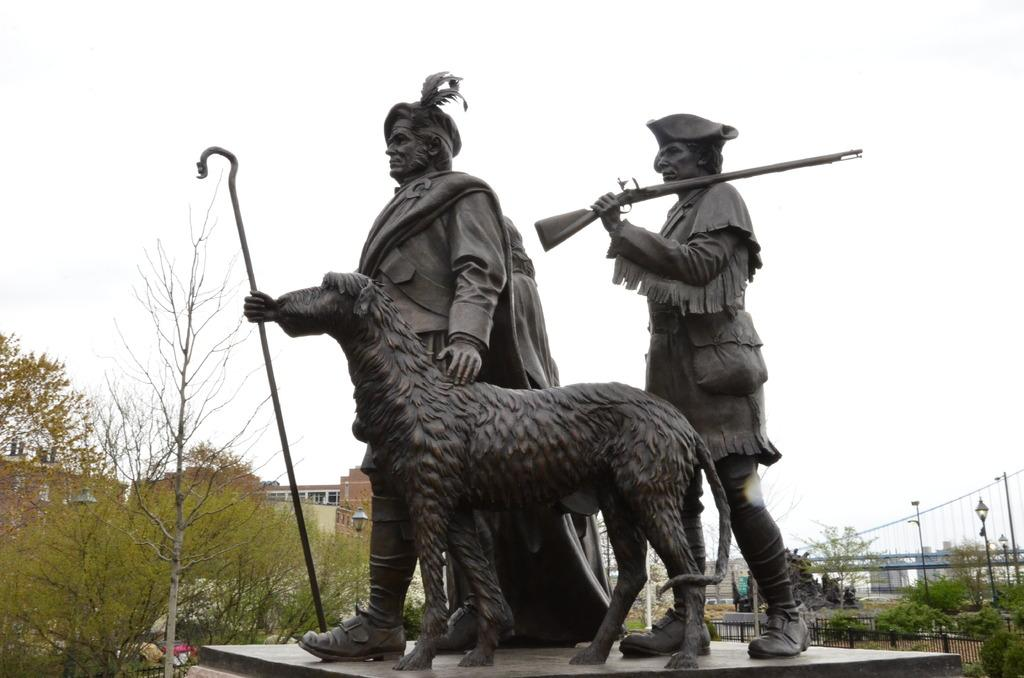What subjects are depicted in the statues in the middle of the image? There are statues of two humans and an animal in the middle of the image. What can be seen on the left side of the image? There are trees and houses on the left side of the image. What is visible at the top of the image? The sky is visible at the top of the image. Is there a stage present in the image where the statues are performing? There is no stage present in the image; it features statues of two humans and an animal. Can you see a family gathering around the statues in the image? There is no family gathering around the statues in the image; it only shows the statues and the surrounding environment. 